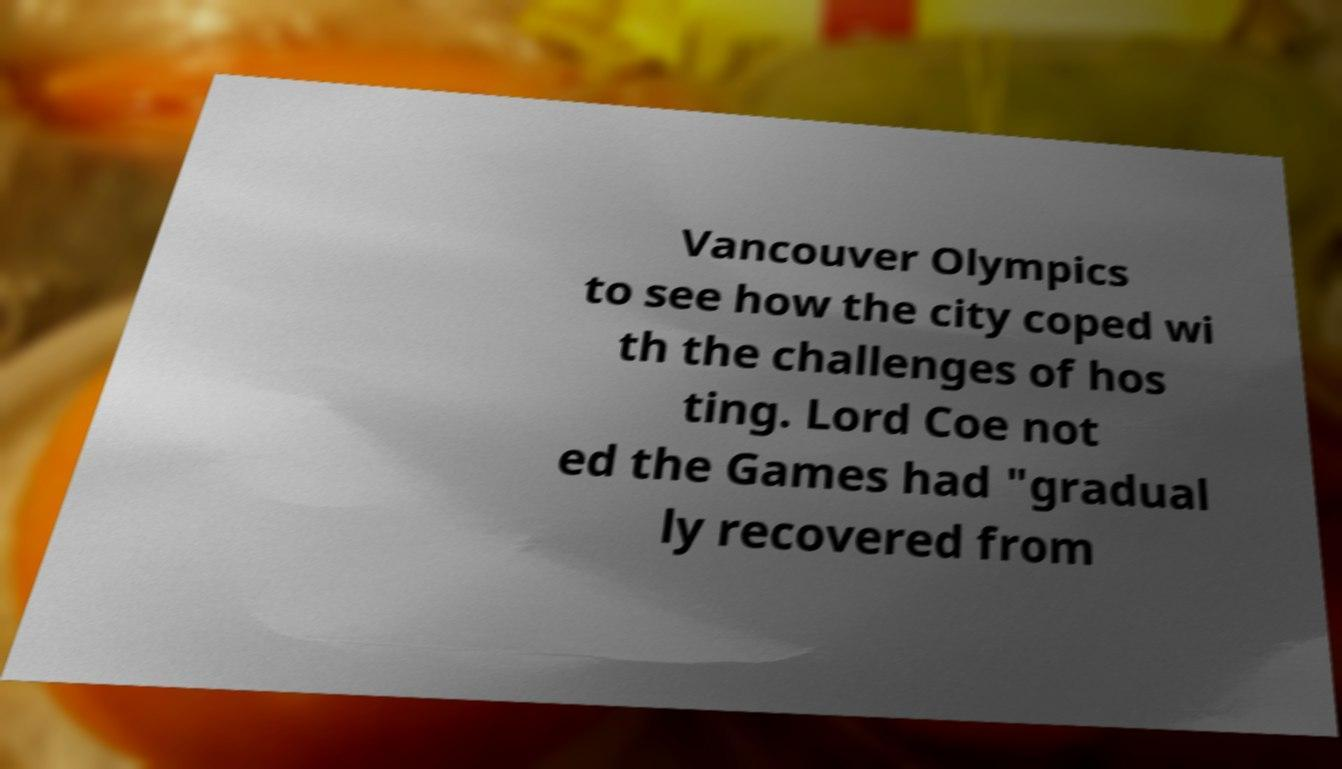Could you extract and type out the text from this image? Vancouver Olympics to see how the city coped wi th the challenges of hos ting. Lord Coe not ed the Games had "gradual ly recovered from 